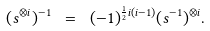Convert formula to latex. <formula><loc_0><loc_0><loc_500><loc_500>( s ^ { \otimes i } ) ^ { - 1 } \ = \ ( - 1 ) ^ { \frac { 1 } { 2 } i ( i - 1 ) } ( s ^ { - 1 } ) ^ { \otimes i } .</formula> 